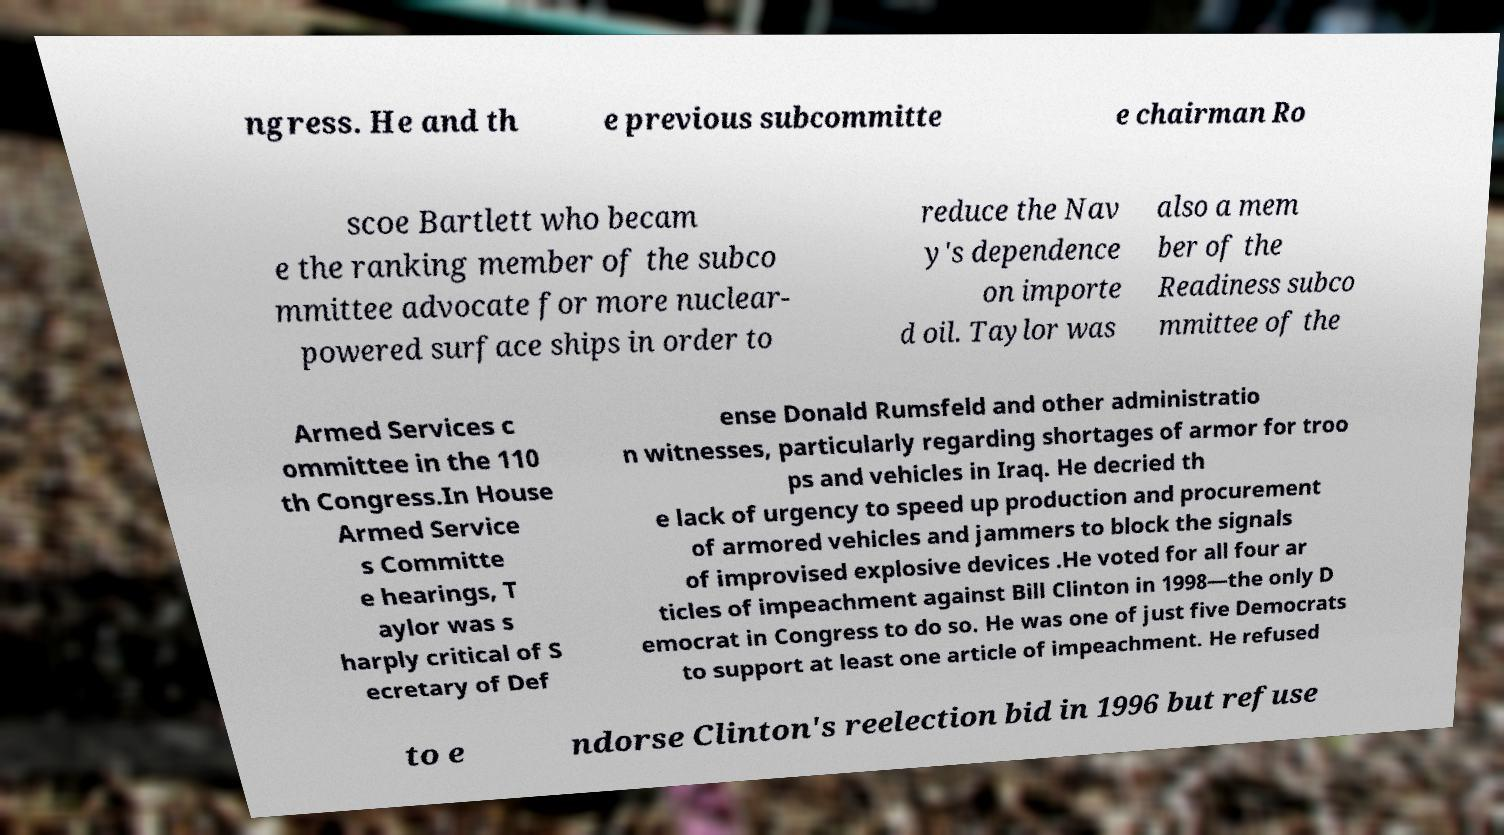What messages or text are displayed in this image? I need them in a readable, typed format. ngress. He and th e previous subcommitte e chairman Ro scoe Bartlett who becam e the ranking member of the subco mmittee advocate for more nuclear- powered surface ships in order to reduce the Nav y's dependence on importe d oil. Taylor was also a mem ber of the Readiness subco mmittee of the Armed Services c ommittee in the 110 th Congress.In House Armed Service s Committe e hearings, T aylor was s harply critical of S ecretary of Def ense Donald Rumsfeld and other administratio n witnesses, particularly regarding shortages of armor for troo ps and vehicles in Iraq. He decried th e lack of urgency to speed up production and procurement of armored vehicles and jammers to block the signals of improvised explosive devices .He voted for all four ar ticles of impeachment against Bill Clinton in 1998—the only D emocrat in Congress to do so. He was one of just five Democrats to support at least one article of impeachment. He refused to e ndorse Clinton's reelection bid in 1996 but refuse 